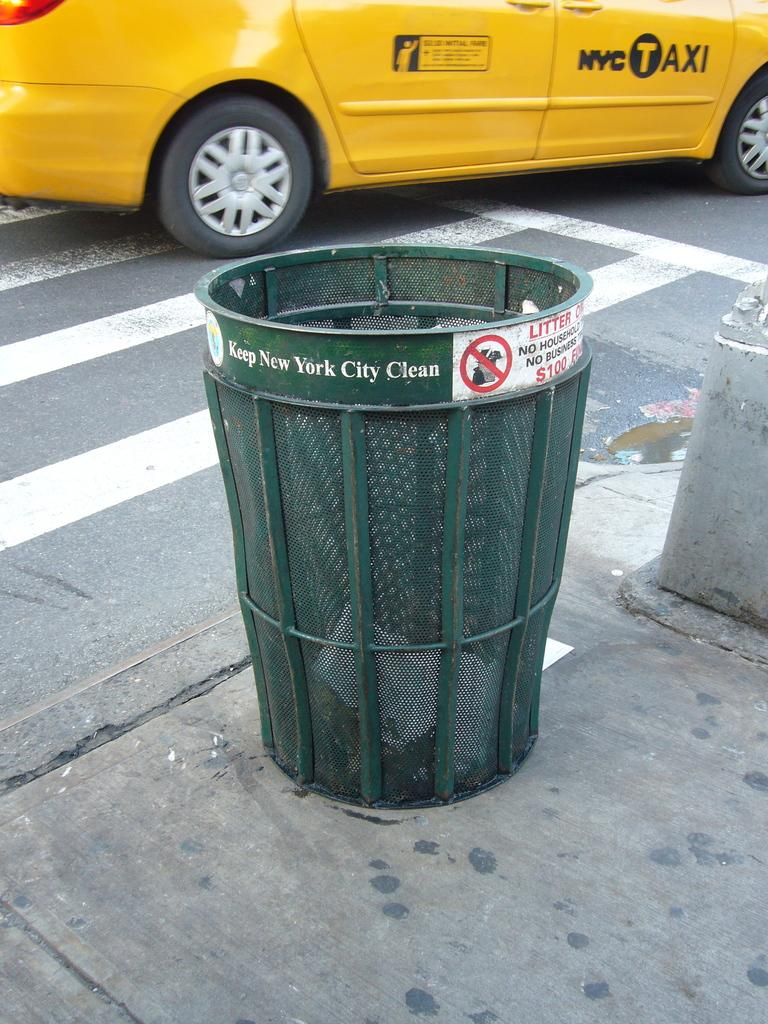Provide a one-sentence caption for the provided image. Green Wire mesh trash can with sign that read Keep New York City Clean. 